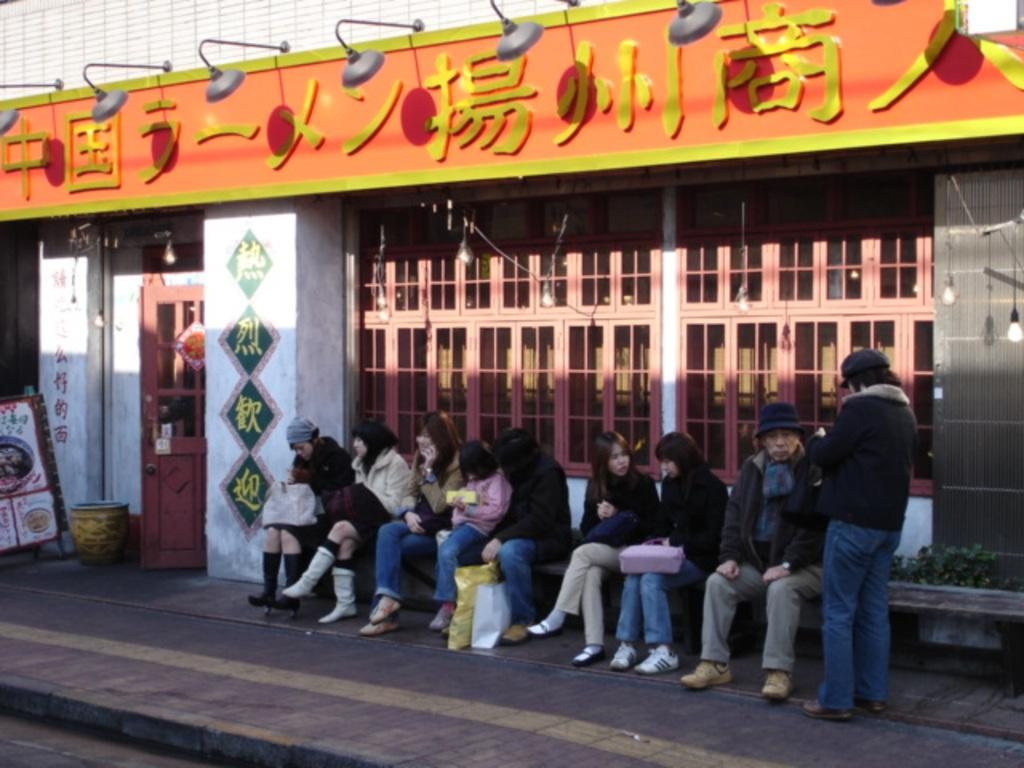What are the people in the image doing? There is a group of people sitting on a bench in the image. Can you describe the person in the image who is not sitting on the bench? There is a person standing on a path in the image. What can be seen behind the people in the image? There is a building visible behind the people. What else can be seen in the background of the image? There are other unspecified things visible in the background of the image. How many ladybugs are crawling on the sheet in the image? There is no sheet or ladybugs present in the image. 